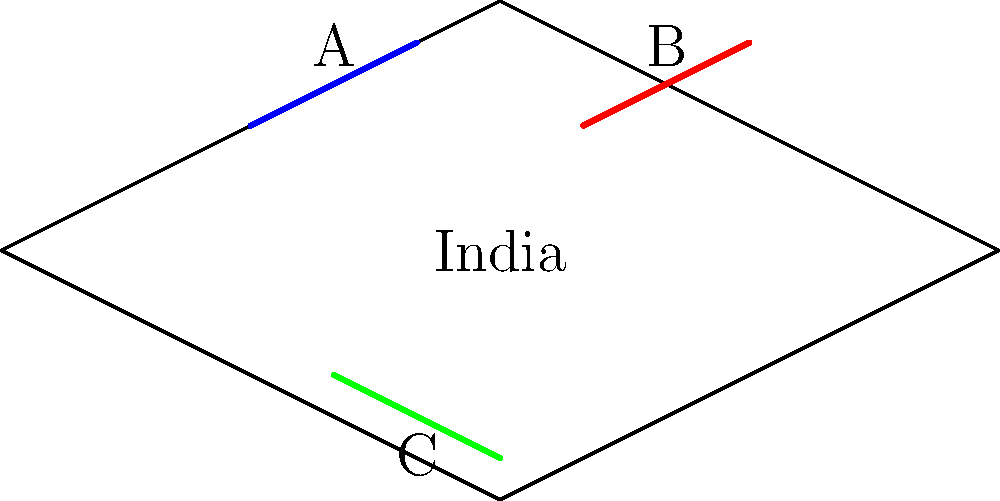On the given topographic map of India, three major mountain ranges are marked as A, B, and C. Which of these represents the Himalayas, and what is its significance for India? To answer this question, let's follow these steps:

1. Analyze the map:
   - The map shows an outline of India with three mountain ranges marked A, B, and C.

2. Identify the location of the Himalayas:
   - The Himalayas are located in the northern part of India.
   - On the map, range A is in the northernmost position.

3. Recognize the Himalayas (A):
   - Range A represents the Himalayas due to its northern location.

4. Understand the significance of the Himalayas for India:
   - Natural barrier: The Himalayas act as a natural border between India and its northern neighbors.
   - Climate influence: They block cold winds from Central Asia and trap monsoon rains.
   - Water source: Major rivers like the Ganges and Yamuna originate from the Himalayas.
   - Biodiversity: The range hosts diverse flora and fauna.
   - Cultural importance: Many sacred sites and pilgrimage destinations are located in the Himalayas.

5. Identify other ranges (for reference):
   - B likely represents the Western Ghats
   - C likely represents the Eastern Ghats
Answer: A; natural barrier, climate influence, water source, biodiversity, cultural importance 